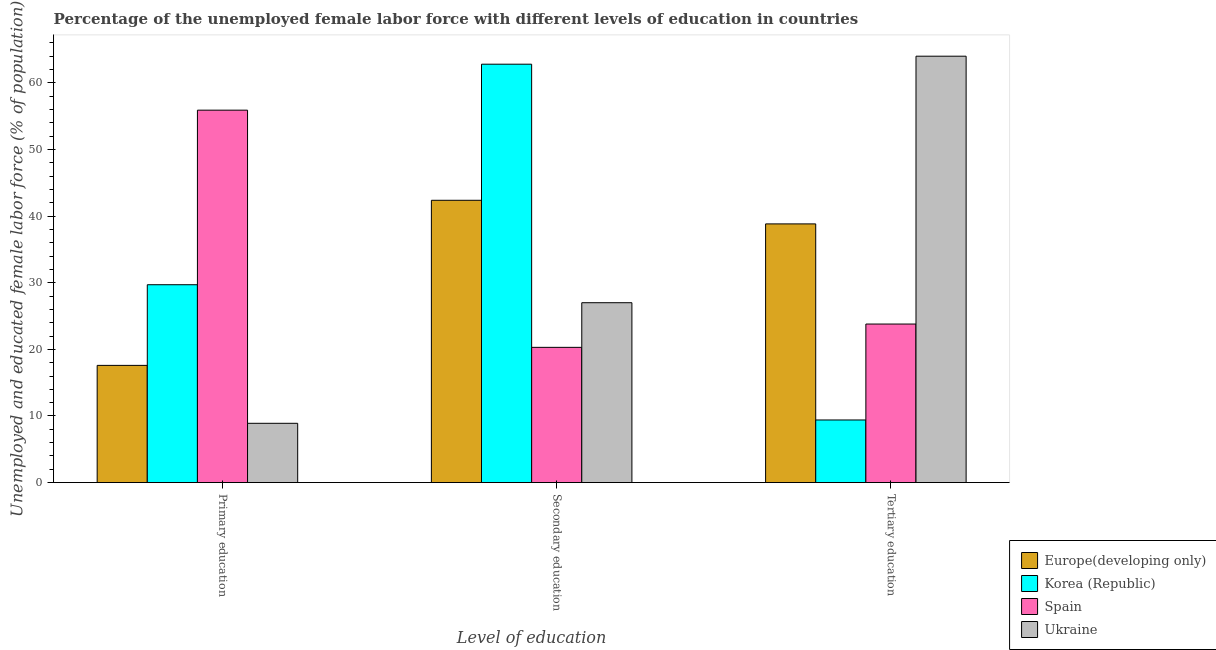How many different coloured bars are there?
Your response must be concise. 4. Are the number of bars per tick equal to the number of legend labels?
Your answer should be compact. Yes. How many bars are there on the 3rd tick from the left?
Give a very brief answer. 4. How many bars are there on the 3rd tick from the right?
Offer a very short reply. 4. What is the label of the 1st group of bars from the left?
Provide a short and direct response. Primary education. What is the percentage of female labor force who received tertiary education in Spain?
Offer a terse response. 23.8. Across all countries, what is the minimum percentage of female labor force who received secondary education?
Provide a succinct answer. 20.3. In which country was the percentage of female labor force who received tertiary education maximum?
Keep it short and to the point. Ukraine. What is the total percentage of female labor force who received primary education in the graph?
Provide a short and direct response. 112.09. What is the difference between the percentage of female labor force who received tertiary education in Ukraine and that in Spain?
Ensure brevity in your answer.  40.2. What is the difference between the percentage of female labor force who received tertiary education in Korea (Republic) and the percentage of female labor force who received secondary education in Ukraine?
Offer a very short reply. -17.6. What is the average percentage of female labor force who received tertiary education per country?
Your answer should be very brief. 34.01. What is the difference between the percentage of female labor force who received secondary education and percentage of female labor force who received tertiary education in Ukraine?
Keep it short and to the point. -37. What is the ratio of the percentage of female labor force who received tertiary education in Spain to that in Korea (Republic)?
Ensure brevity in your answer.  2.53. Is the percentage of female labor force who received primary education in Spain less than that in Ukraine?
Your response must be concise. No. Is the difference between the percentage of female labor force who received primary education in Europe(developing only) and Ukraine greater than the difference between the percentage of female labor force who received secondary education in Europe(developing only) and Ukraine?
Give a very brief answer. No. What is the difference between the highest and the second highest percentage of female labor force who received primary education?
Give a very brief answer. 26.2. What is the difference between the highest and the lowest percentage of female labor force who received primary education?
Provide a succinct answer. 47. Is the sum of the percentage of female labor force who received secondary education in Spain and Korea (Republic) greater than the maximum percentage of female labor force who received tertiary education across all countries?
Your answer should be very brief. Yes. What does the 3rd bar from the left in Primary education represents?
Provide a short and direct response. Spain. What does the 4th bar from the right in Primary education represents?
Offer a terse response. Europe(developing only). Does the graph contain grids?
Your answer should be very brief. No. What is the title of the graph?
Make the answer very short. Percentage of the unemployed female labor force with different levels of education in countries. Does "Pakistan" appear as one of the legend labels in the graph?
Offer a terse response. No. What is the label or title of the X-axis?
Offer a terse response. Level of education. What is the label or title of the Y-axis?
Provide a succinct answer. Unemployed and educated female labor force (% of population). What is the Unemployed and educated female labor force (% of population) in Europe(developing only) in Primary education?
Ensure brevity in your answer.  17.59. What is the Unemployed and educated female labor force (% of population) of Korea (Republic) in Primary education?
Provide a succinct answer. 29.7. What is the Unemployed and educated female labor force (% of population) of Spain in Primary education?
Provide a short and direct response. 55.9. What is the Unemployed and educated female labor force (% of population) of Ukraine in Primary education?
Your answer should be compact. 8.9. What is the Unemployed and educated female labor force (% of population) in Europe(developing only) in Secondary education?
Keep it short and to the point. 42.37. What is the Unemployed and educated female labor force (% of population) of Korea (Republic) in Secondary education?
Offer a terse response. 62.8. What is the Unemployed and educated female labor force (% of population) of Spain in Secondary education?
Keep it short and to the point. 20.3. What is the Unemployed and educated female labor force (% of population) of Ukraine in Secondary education?
Offer a terse response. 27. What is the Unemployed and educated female labor force (% of population) in Europe(developing only) in Tertiary education?
Your response must be concise. 38.83. What is the Unemployed and educated female labor force (% of population) of Korea (Republic) in Tertiary education?
Offer a terse response. 9.4. What is the Unemployed and educated female labor force (% of population) in Spain in Tertiary education?
Offer a terse response. 23.8. What is the Unemployed and educated female labor force (% of population) of Ukraine in Tertiary education?
Give a very brief answer. 64. Across all Level of education, what is the maximum Unemployed and educated female labor force (% of population) in Europe(developing only)?
Offer a terse response. 42.37. Across all Level of education, what is the maximum Unemployed and educated female labor force (% of population) in Korea (Republic)?
Your response must be concise. 62.8. Across all Level of education, what is the maximum Unemployed and educated female labor force (% of population) in Spain?
Your response must be concise. 55.9. Across all Level of education, what is the minimum Unemployed and educated female labor force (% of population) in Europe(developing only)?
Give a very brief answer. 17.59. Across all Level of education, what is the minimum Unemployed and educated female labor force (% of population) of Korea (Republic)?
Your response must be concise. 9.4. Across all Level of education, what is the minimum Unemployed and educated female labor force (% of population) in Spain?
Offer a very short reply. 20.3. Across all Level of education, what is the minimum Unemployed and educated female labor force (% of population) of Ukraine?
Give a very brief answer. 8.9. What is the total Unemployed and educated female labor force (% of population) of Europe(developing only) in the graph?
Make the answer very short. 98.8. What is the total Unemployed and educated female labor force (% of population) in Korea (Republic) in the graph?
Ensure brevity in your answer.  101.9. What is the total Unemployed and educated female labor force (% of population) in Ukraine in the graph?
Keep it short and to the point. 99.9. What is the difference between the Unemployed and educated female labor force (% of population) of Europe(developing only) in Primary education and that in Secondary education?
Give a very brief answer. -24.78. What is the difference between the Unemployed and educated female labor force (% of population) in Korea (Republic) in Primary education and that in Secondary education?
Your response must be concise. -33.1. What is the difference between the Unemployed and educated female labor force (% of population) of Spain in Primary education and that in Secondary education?
Offer a very short reply. 35.6. What is the difference between the Unemployed and educated female labor force (% of population) in Ukraine in Primary education and that in Secondary education?
Offer a very short reply. -18.1. What is the difference between the Unemployed and educated female labor force (% of population) of Europe(developing only) in Primary education and that in Tertiary education?
Give a very brief answer. -21.24. What is the difference between the Unemployed and educated female labor force (% of population) of Korea (Republic) in Primary education and that in Tertiary education?
Offer a terse response. 20.3. What is the difference between the Unemployed and educated female labor force (% of population) in Spain in Primary education and that in Tertiary education?
Provide a short and direct response. 32.1. What is the difference between the Unemployed and educated female labor force (% of population) of Ukraine in Primary education and that in Tertiary education?
Offer a terse response. -55.1. What is the difference between the Unemployed and educated female labor force (% of population) in Europe(developing only) in Secondary education and that in Tertiary education?
Ensure brevity in your answer.  3.54. What is the difference between the Unemployed and educated female labor force (% of population) in Korea (Republic) in Secondary education and that in Tertiary education?
Your answer should be compact. 53.4. What is the difference between the Unemployed and educated female labor force (% of population) in Ukraine in Secondary education and that in Tertiary education?
Give a very brief answer. -37. What is the difference between the Unemployed and educated female labor force (% of population) in Europe(developing only) in Primary education and the Unemployed and educated female labor force (% of population) in Korea (Republic) in Secondary education?
Your answer should be very brief. -45.21. What is the difference between the Unemployed and educated female labor force (% of population) in Europe(developing only) in Primary education and the Unemployed and educated female labor force (% of population) in Spain in Secondary education?
Your answer should be very brief. -2.71. What is the difference between the Unemployed and educated female labor force (% of population) in Europe(developing only) in Primary education and the Unemployed and educated female labor force (% of population) in Ukraine in Secondary education?
Give a very brief answer. -9.41. What is the difference between the Unemployed and educated female labor force (% of population) in Korea (Republic) in Primary education and the Unemployed and educated female labor force (% of population) in Spain in Secondary education?
Ensure brevity in your answer.  9.4. What is the difference between the Unemployed and educated female labor force (% of population) of Korea (Republic) in Primary education and the Unemployed and educated female labor force (% of population) of Ukraine in Secondary education?
Your answer should be very brief. 2.7. What is the difference between the Unemployed and educated female labor force (% of population) of Spain in Primary education and the Unemployed and educated female labor force (% of population) of Ukraine in Secondary education?
Provide a short and direct response. 28.9. What is the difference between the Unemployed and educated female labor force (% of population) of Europe(developing only) in Primary education and the Unemployed and educated female labor force (% of population) of Korea (Republic) in Tertiary education?
Your answer should be very brief. 8.19. What is the difference between the Unemployed and educated female labor force (% of population) of Europe(developing only) in Primary education and the Unemployed and educated female labor force (% of population) of Spain in Tertiary education?
Give a very brief answer. -6.21. What is the difference between the Unemployed and educated female labor force (% of population) in Europe(developing only) in Primary education and the Unemployed and educated female labor force (% of population) in Ukraine in Tertiary education?
Provide a short and direct response. -46.41. What is the difference between the Unemployed and educated female labor force (% of population) in Korea (Republic) in Primary education and the Unemployed and educated female labor force (% of population) in Ukraine in Tertiary education?
Your answer should be compact. -34.3. What is the difference between the Unemployed and educated female labor force (% of population) in Spain in Primary education and the Unemployed and educated female labor force (% of population) in Ukraine in Tertiary education?
Give a very brief answer. -8.1. What is the difference between the Unemployed and educated female labor force (% of population) of Europe(developing only) in Secondary education and the Unemployed and educated female labor force (% of population) of Korea (Republic) in Tertiary education?
Give a very brief answer. 32.97. What is the difference between the Unemployed and educated female labor force (% of population) of Europe(developing only) in Secondary education and the Unemployed and educated female labor force (% of population) of Spain in Tertiary education?
Offer a very short reply. 18.57. What is the difference between the Unemployed and educated female labor force (% of population) of Europe(developing only) in Secondary education and the Unemployed and educated female labor force (% of population) of Ukraine in Tertiary education?
Provide a succinct answer. -21.63. What is the difference between the Unemployed and educated female labor force (% of population) in Korea (Republic) in Secondary education and the Unemployed and educated female labor force (% of population) in Spain in Tertiary education?
Your answer should be compact. 39. What is the difference between the Unemployed and educated female labor force (% of population) of Spain in Secondary education and the Unemployed and educated female labor force (% of population) of Ukraine in Tertiary education?
Ensure brevity in your answer.  -43.7. What is the average Unemployed and educated female labor force (% of population) in Europe(developing only) per Level of education?
Offer a very short reply. 32.93. What is the average Unemployed and educated female labor force (% of population) in Korea (Republic) per Level of education?
Keep it short and to the point. 33.97. What is the average Unemployed and educated female labor force (% of population) of Spain per Level of education?
Make the answer very short. 33.33. What is the average Unemployed and educated female labor force (% of population) of Ukraine per Level of education?
Ensure brevity in your answer.  33.3. What is the difference between the Unemployed and educated female labor force (% of population) of Europe(developing only) and Unemployed and educated female labor force (% of population) of Korea (Republic) in Primary education?
Your answer should be very brief. -12.11. What is the difference between the Unemployed and educated female labor force (% of population) in Europe(developing only) and Unemployed and educated female labor force (% of population) in Spain in Primary education?
Offer a very short reply. -38.31. What is the difference between the Unemployed and educated female labor force (% of population) in Europe(developing only) and Unemployed and educated female labor force (% of population) in Ukraine in Primary education?
Provide a succinct answer. 8.69. What is the difference between the Unemployed and educated female labor force (% of population) of Korea (Republic) and Unemployed and educated female labor force (% of population) of Spain in Primary education?
Make the answer very short. -26.2. What is the difference between the Unemployed and educated female labor force (% of population) of Korea (Republic) and Unemployed and educated female labor force (% of population) of Ukraine in Primary education?
Provide a short and direct response. 20.8. What is the difference between the Unemployed and educated female labor force (% of population) of Europe(developing only) and Unemployed and educated female labor force (% of population) of Korea (Republic) in Secondary education?
Provide a short and direct response. -20.43. What is the difference between the Unemployed and educated female labor force (% of population) of Europe(developing only) and Unemployed and educated female labor force (% of population) of Spain in Secondary education?
Provide a succinct answer. 22.07. What is the difference between the Unemployed and educated female labor force (% of population) in Europe(developing only) and Unemployed and educated female labor force (% of population) in Ukraine in Secondary education?
Make the answer very short. 15.37. What is the difference between the Unemployed and educated female labor force (% of population) of Korea (Republic) and Unemployed and educated female labor force (% of population) of Spain in Secondary education?
Make the answer very short. 42.5. What is the difference between the Unemployed and educated female labor force (% of population) of Korea (Republic) and Unemployed and educated female labor force (% of population) of Ukraine in Secondary education?
Your answer should be compact. 35.8. What is the difference between the Unemployed and educated female labor force (% of population) of Europe(developing only) and Unemployed and educated female labor force (% of population) of Korea (Republic) in Tertiary education?
Make the answer very short. 29.43. What is the difference between the Unemployed and educated female labor force (% of population) of Europe(developing only) and Unemployed and educated female labor force (% of population) of Spain in Tertiary education?
Ensure brevity in your answer.  15.03. What is the difference between the Unemployed and educated female labor force (% of population) of Europe(developing only) and Unemployed and educated female labor force (% of population) of Ukraine in Tertiary education?
Offer a very short reply. -25.17. What is the difference between the Unemployed and educated female labor force (% of population) in Korea (Republic) and Unemployed and educated female labor force (% of population) in Spain in Tertiary education?
Make the answer very short. -14.4. What is the difference between the Unemployed and educated female labor force (% of population) in Korea (Republic) and Unemployed and educated female labor force (% of population) in Ukraine in Tertiary education?
Provide a short and direct response. -54.6. What is the difference between the Unemployed and educated female labor force (% of population) in Spain and Unemployed and educated female labor force (% of population) in Ukraine in Tertiary education?
Your answer should be very brief. -40.2. What is the ratio of the Unemployed and educated female labor force (% of population) in Europe(developing only) in Primary education to that in Secondary education?
Keep it short and to the point. 0.42. What is the ratio of the Unemployed and educated female labor force (% of population) of Korea (Republic) in Primary education to that in Secondary education?
Your answer should be very brief. 0.47. What is the ratio of the Unemployed and educated female labor force (% of population) of Spain in Primary education to that in Secondary education?
Provide a succinct answer. 2.75. What is the ratio of the Unemployed and educated female labor force (% of population) of Ukraine in Primary education to that in Secondary education?
Keep it short and to the point. 0.33. What is the ratio of the Unemployed and educated female labor force (% of population) of Europe(developing only) in Primary education to that in Tertiary education?
Provide a succinct answer. 0.45. What is the ratio of the Unemployed and educated female labor force (% of population) of Korea (Republic) in Primary education to that in Tertiary education?
Provide a short and direct response. 3.16. What is the ratio of the Unemployed and educated female labor force (% of population) of Spain in Primary education to that in Tertiary education?
Keep it short and to the point. 2.35. What is the ratio of the Unemployed and educated female labor force (% of population) of Ukraine in Primary education to that in Tertiary education?
Offer a terse response. 0.14. What is the ratio of the Unemployed and educated female labor force (% of population) in Europe(developing only) in Secondary education to that in Tertiary education?
Keep it short and to the point. 1.09. What is the ratio of the Unemployed and educated female labor force (% of population) of Korea (Republic) in Secondary education to that in Tertiary education?
Provide a short and direct response. 6.68. What is the ratio of the Unemployed and educated female labor force (% of population) in Spain in Secondary education to that in Tertiary education?
Give a very brief answer. 0.85. What is the ratio of the Unemployed and educated female labor force (% of population) in Ukraine in Secondary education to that in Tertiary education?
Your answer should be compact. 0.42. What is the difference between the highest and the second highest Unemployed and educated female labor force (% of population) in Europe(developing only)?
Your response must be concise. 3.54. What is the difference between the highest and the second highest Unemployed and educated female labor force (% of population) of Korea (Republic)?
Give a very brief answer. 33.1. What is the difference between the highest and the second highest Unemployed and educated female labor force (% of population) of Spain?
Your answer should be very brief. 32.1. What is the difference between the highest and the lowest Unemployed and educated female labor force (% of population) in Europe(developing only)?
Offer a very short reply. 24.78. What is the difference between the highest and the lowest Unemployed and educated female labor force (% of population) in Korea (Republic)?
Your answer should be compact. 53.4. What is the difference between the highest and the lowest Unemployed and educated female labor force (% of population) of Spain?
Provide a short and direct response. 35.6. What is the difference between the highest and the lowest Unemployed and educated female labor force (% of population) of Ukraine?
Provide a short and direct response. 55.1. 